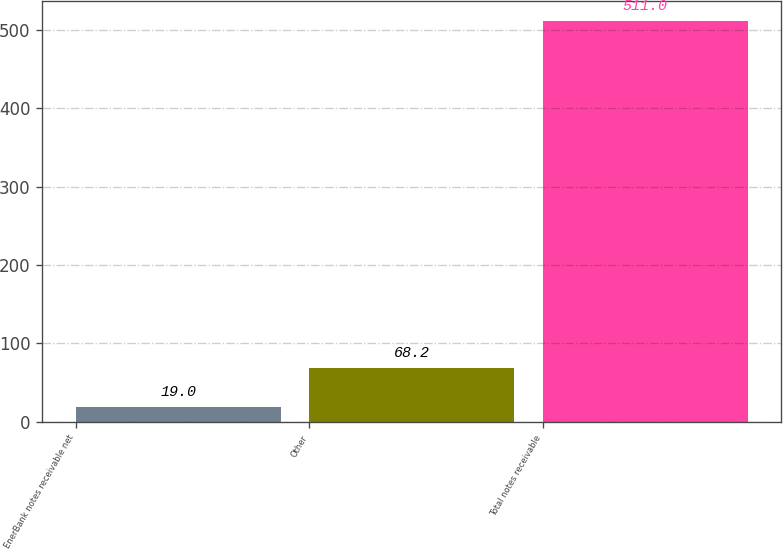Convert chart to OTSL. <chart><loc_0><loc_0><loc_500><loc_500><bar_chart><fcel>EnerBank notes receivable net<fcel>Other<fcel>Total notes receivable<nl><fcel>19<fcel>68.2<fcel>511<nl></chart> 